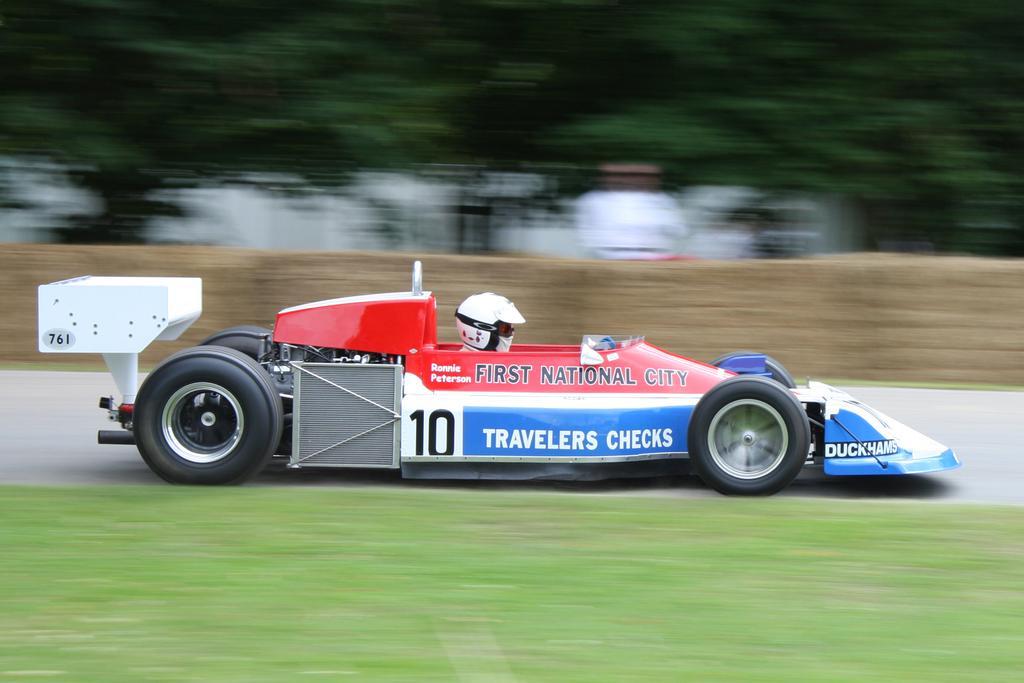In one or two sentences, can you explain what this image depicts? In this image I can see a vehicle which is in red,white and blue color. One person is sitting inside and wearing helmet. Background is blurred. 